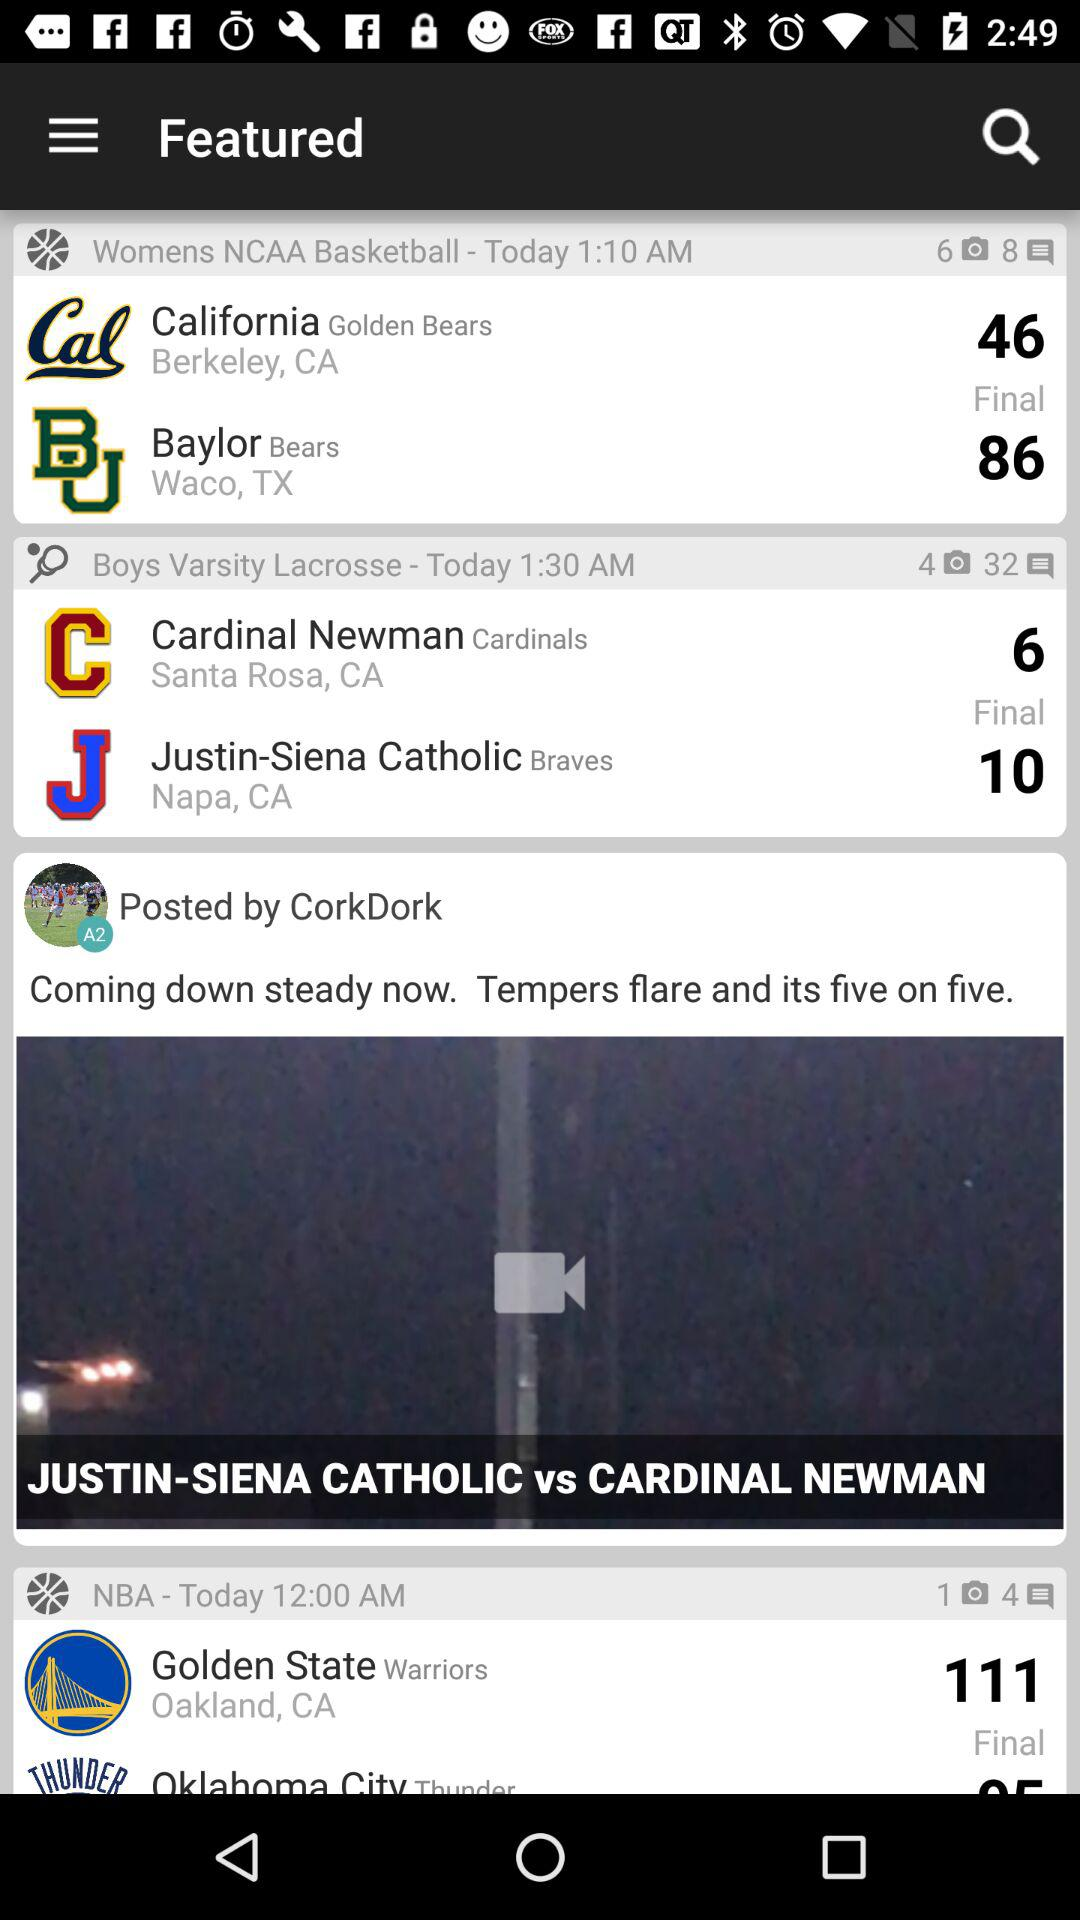What team got a 46 score? The team name is the California Golden Bears. 